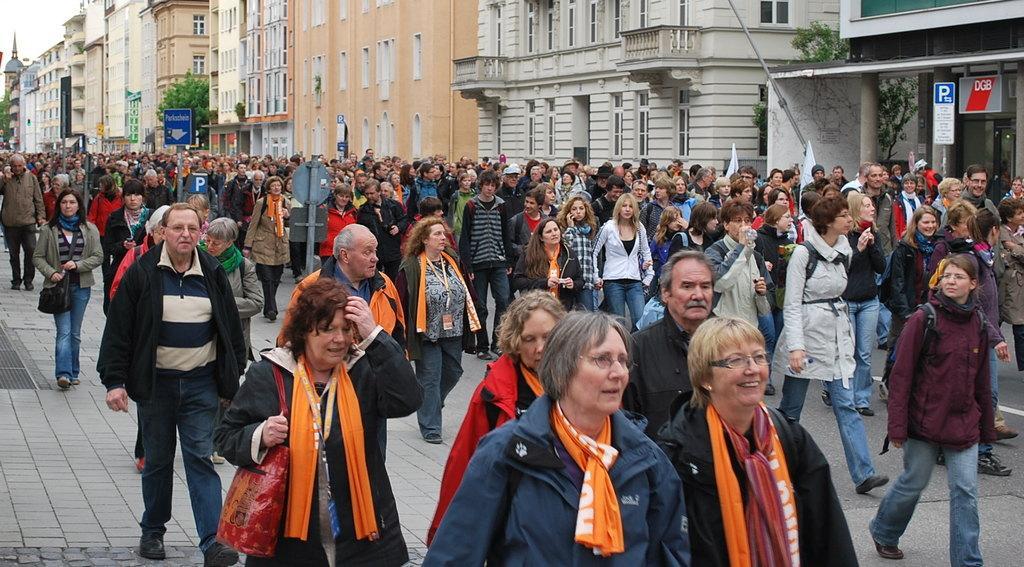Please provide a concise description of this image. In this image we can see people walking on the road. In the background of the image there are buildings, poles, trees. 